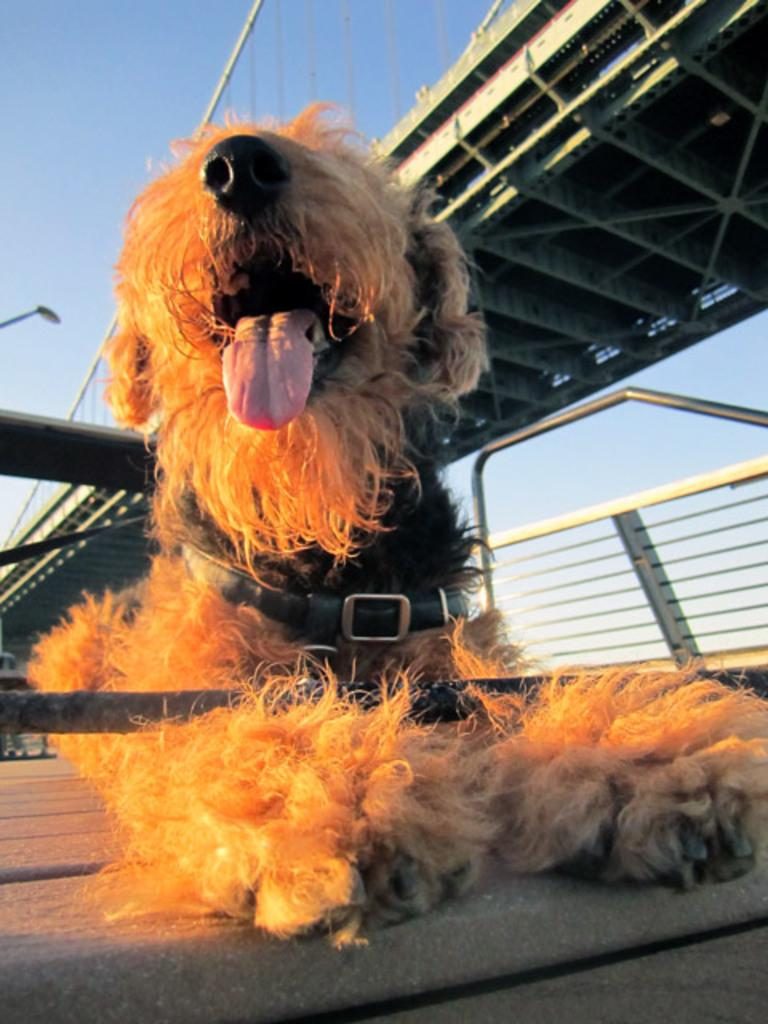What type of animal is in the image? There is a brown dog in the image. What is the dog doing in the image? The dog is resting on a surface. What can be seen in the background of the image? There is a bridge at the top of the image. What is the condition of the sky in the image? The sky is clear and visible in the image. What type of quilt is covering the dog in the image? There is no quilt present in the image; the dog is resting on a surface without any covering. What time of day is depicted in the image, considering the clear sky? The time of day cannot be determined solely from the clear sky; additional information about the sun's position or shadows would be needed. 